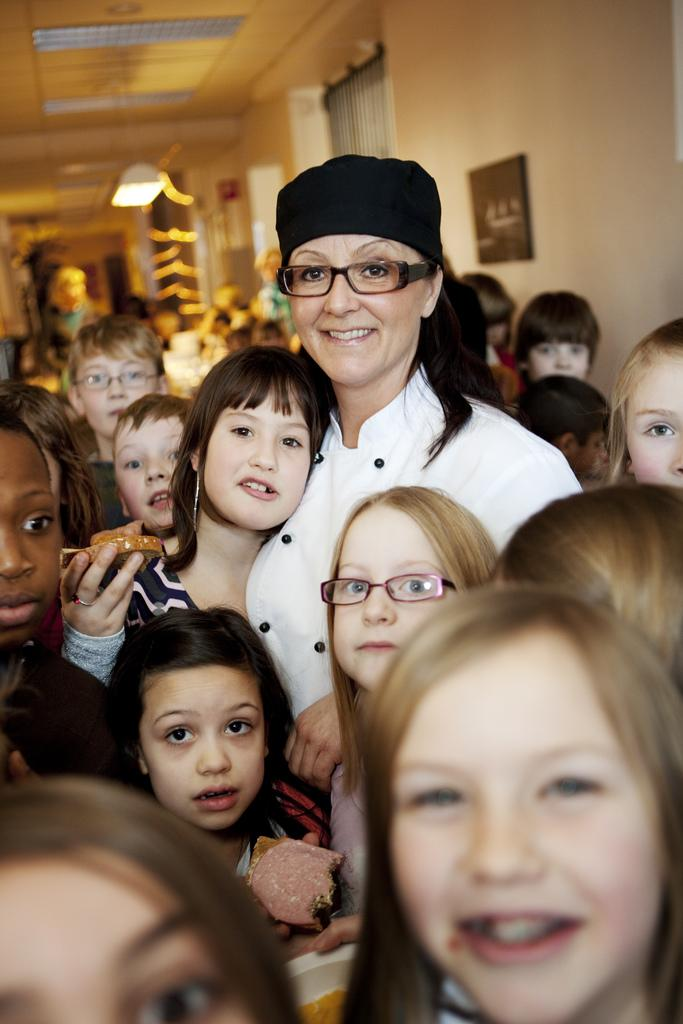How many people are in the image? There is a group of people in the image. What are the people in the image doing? The people are posing for a camera. What can be seen in the background of the image? There is a light, a frame, and a wall in the background of the image. What is the weight of the love shown in the image? There is no love present in the image, and therefore no weight can be attributed to it. 